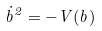<formula> <loc_0><loc_0><loc_500><loc_500>\dot { b } ^ { 2 } = - V ( b )</formula> 